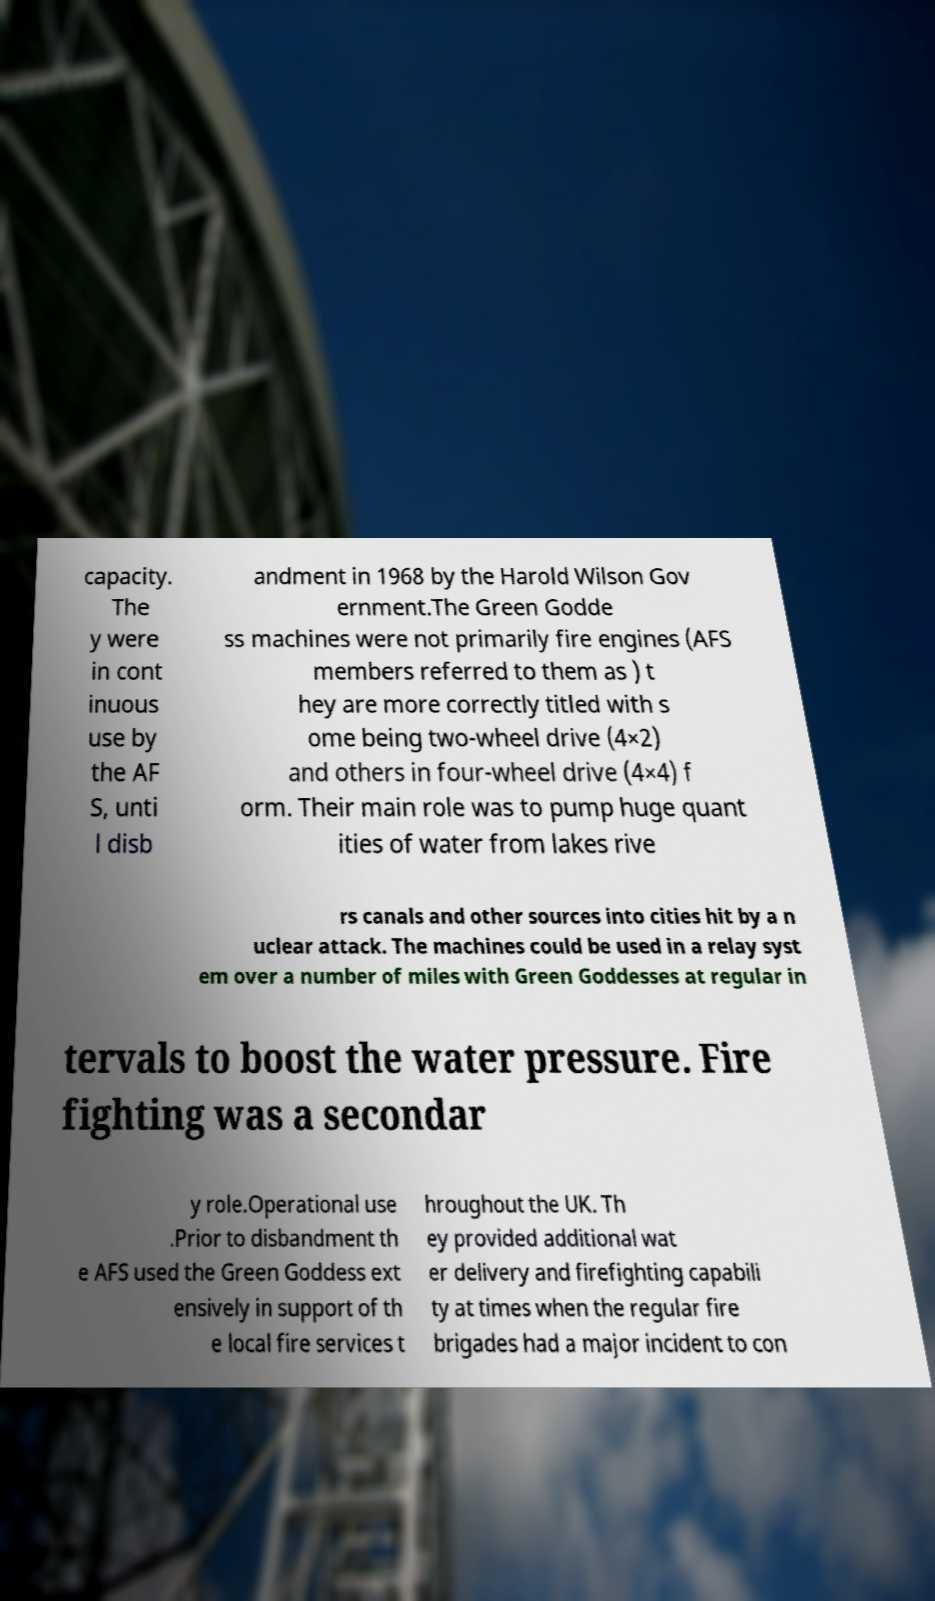Can you read and provide the text displayed in the image?This photo seems to have some interesting text. Can you extract and type it out for me? capacity. The y were in cont inuous use by the AF S, unti l disb andment in 1968 by the Harold Wilson Gov ernment.The Green Godde ss machines were not primarily fire engines (AFS members referred to them as ) t hey are more correctly titled with s ome being two-wheel drive (4×2) and others in four-wheel drive (4×4) f orm. Their main role was to pump huge quant ities of water from lakes rive rs canals and other sources into cities hit by a n uclear attack. The machines could be used in a relay syst em over a number of miles with Green Goddesses at regular in tervals to boost the water pressure. Fire fighting was a secondar y role.Operational use .Prior to disbandment th e AFS used the Green Goddess ext ensively in support of th e local fire services t hroughout the UK. Th ey provided additional wat er delivery and firefighting capabili ty at times when the regular fire brigades had a major incident to con 